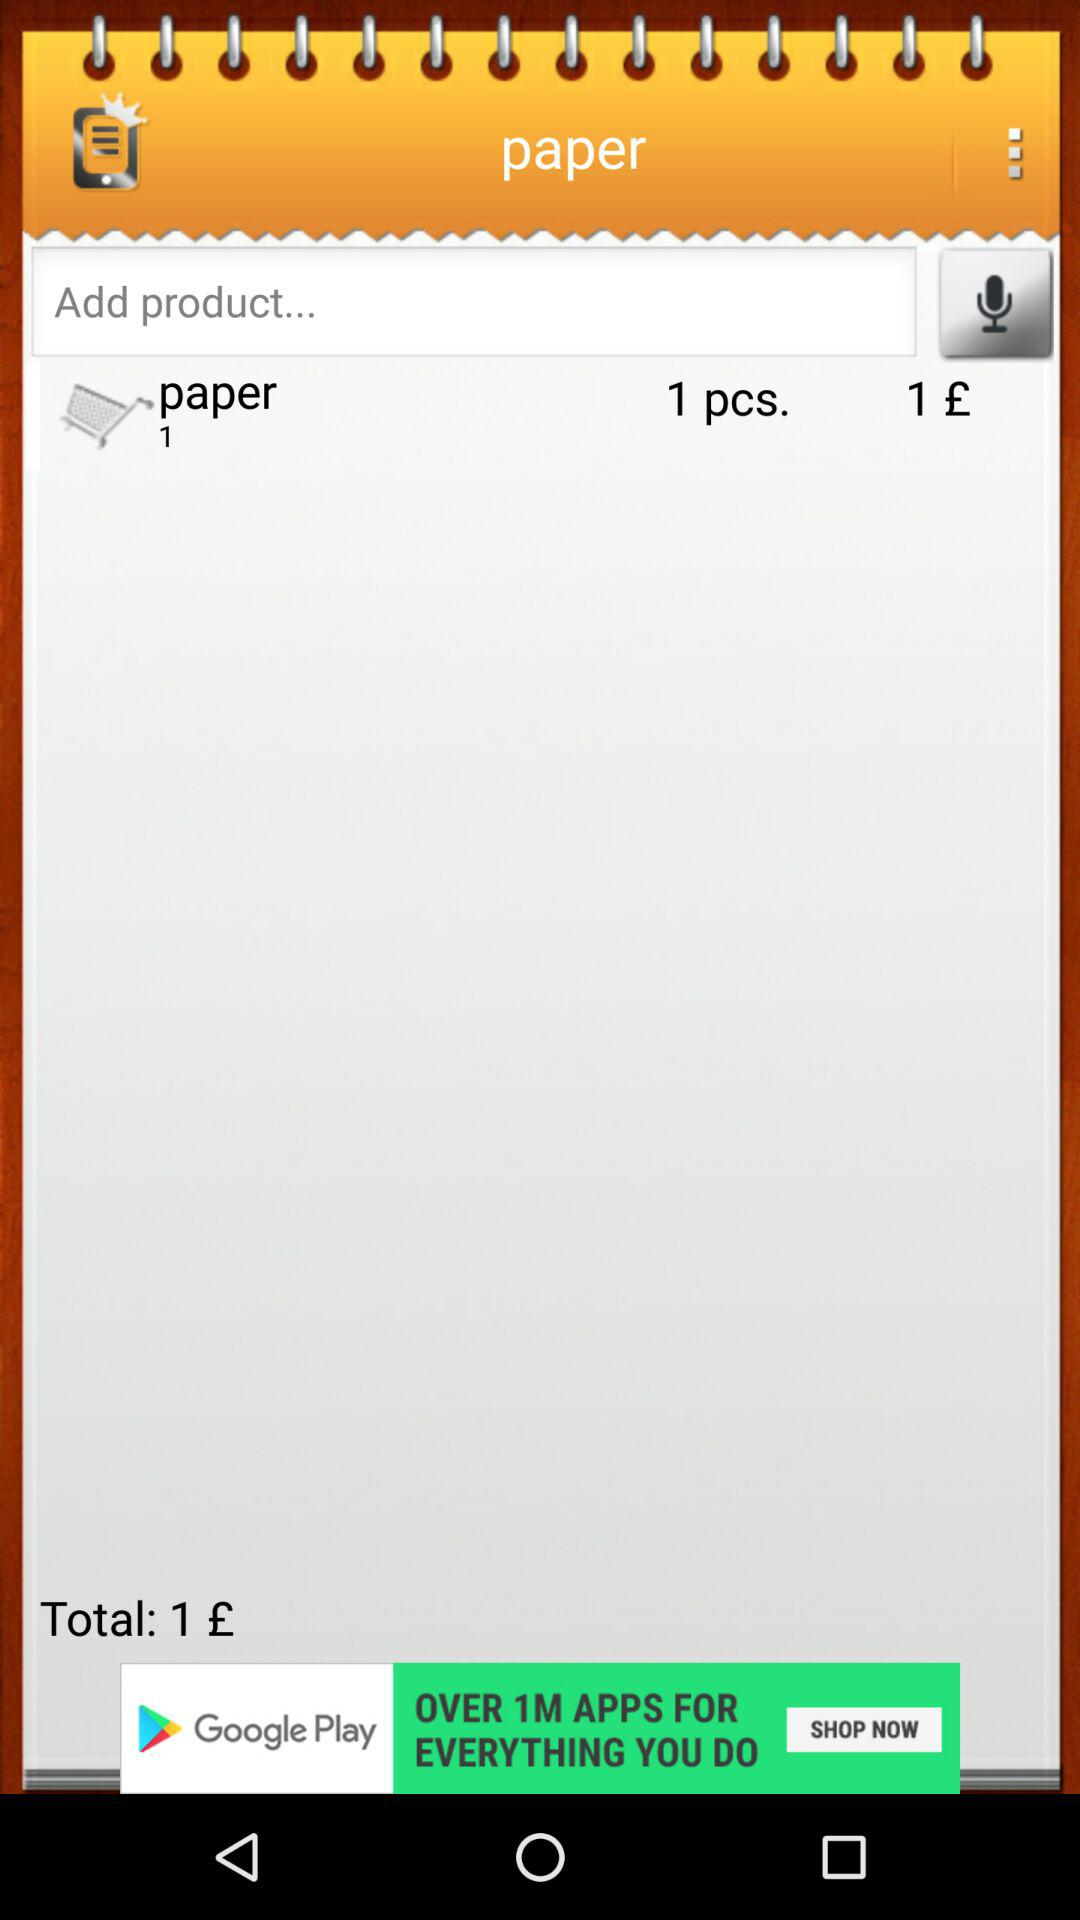How many pieces of paper are there? There is 1 piece of paper. 